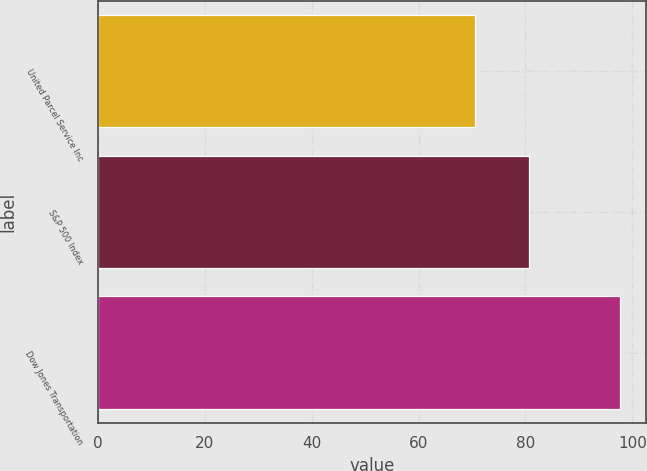Convert chart to OTSL. <chart><loc_0><loc_0><loc_500><loc_500><bar_chart><fcel>United Parcel Service Inc<fcel>S&P 500 Index<fcel>Dow Jones Transportation<nl><fcel>70.48<fcel>80.74<fcel>97.72<nl></chart> 